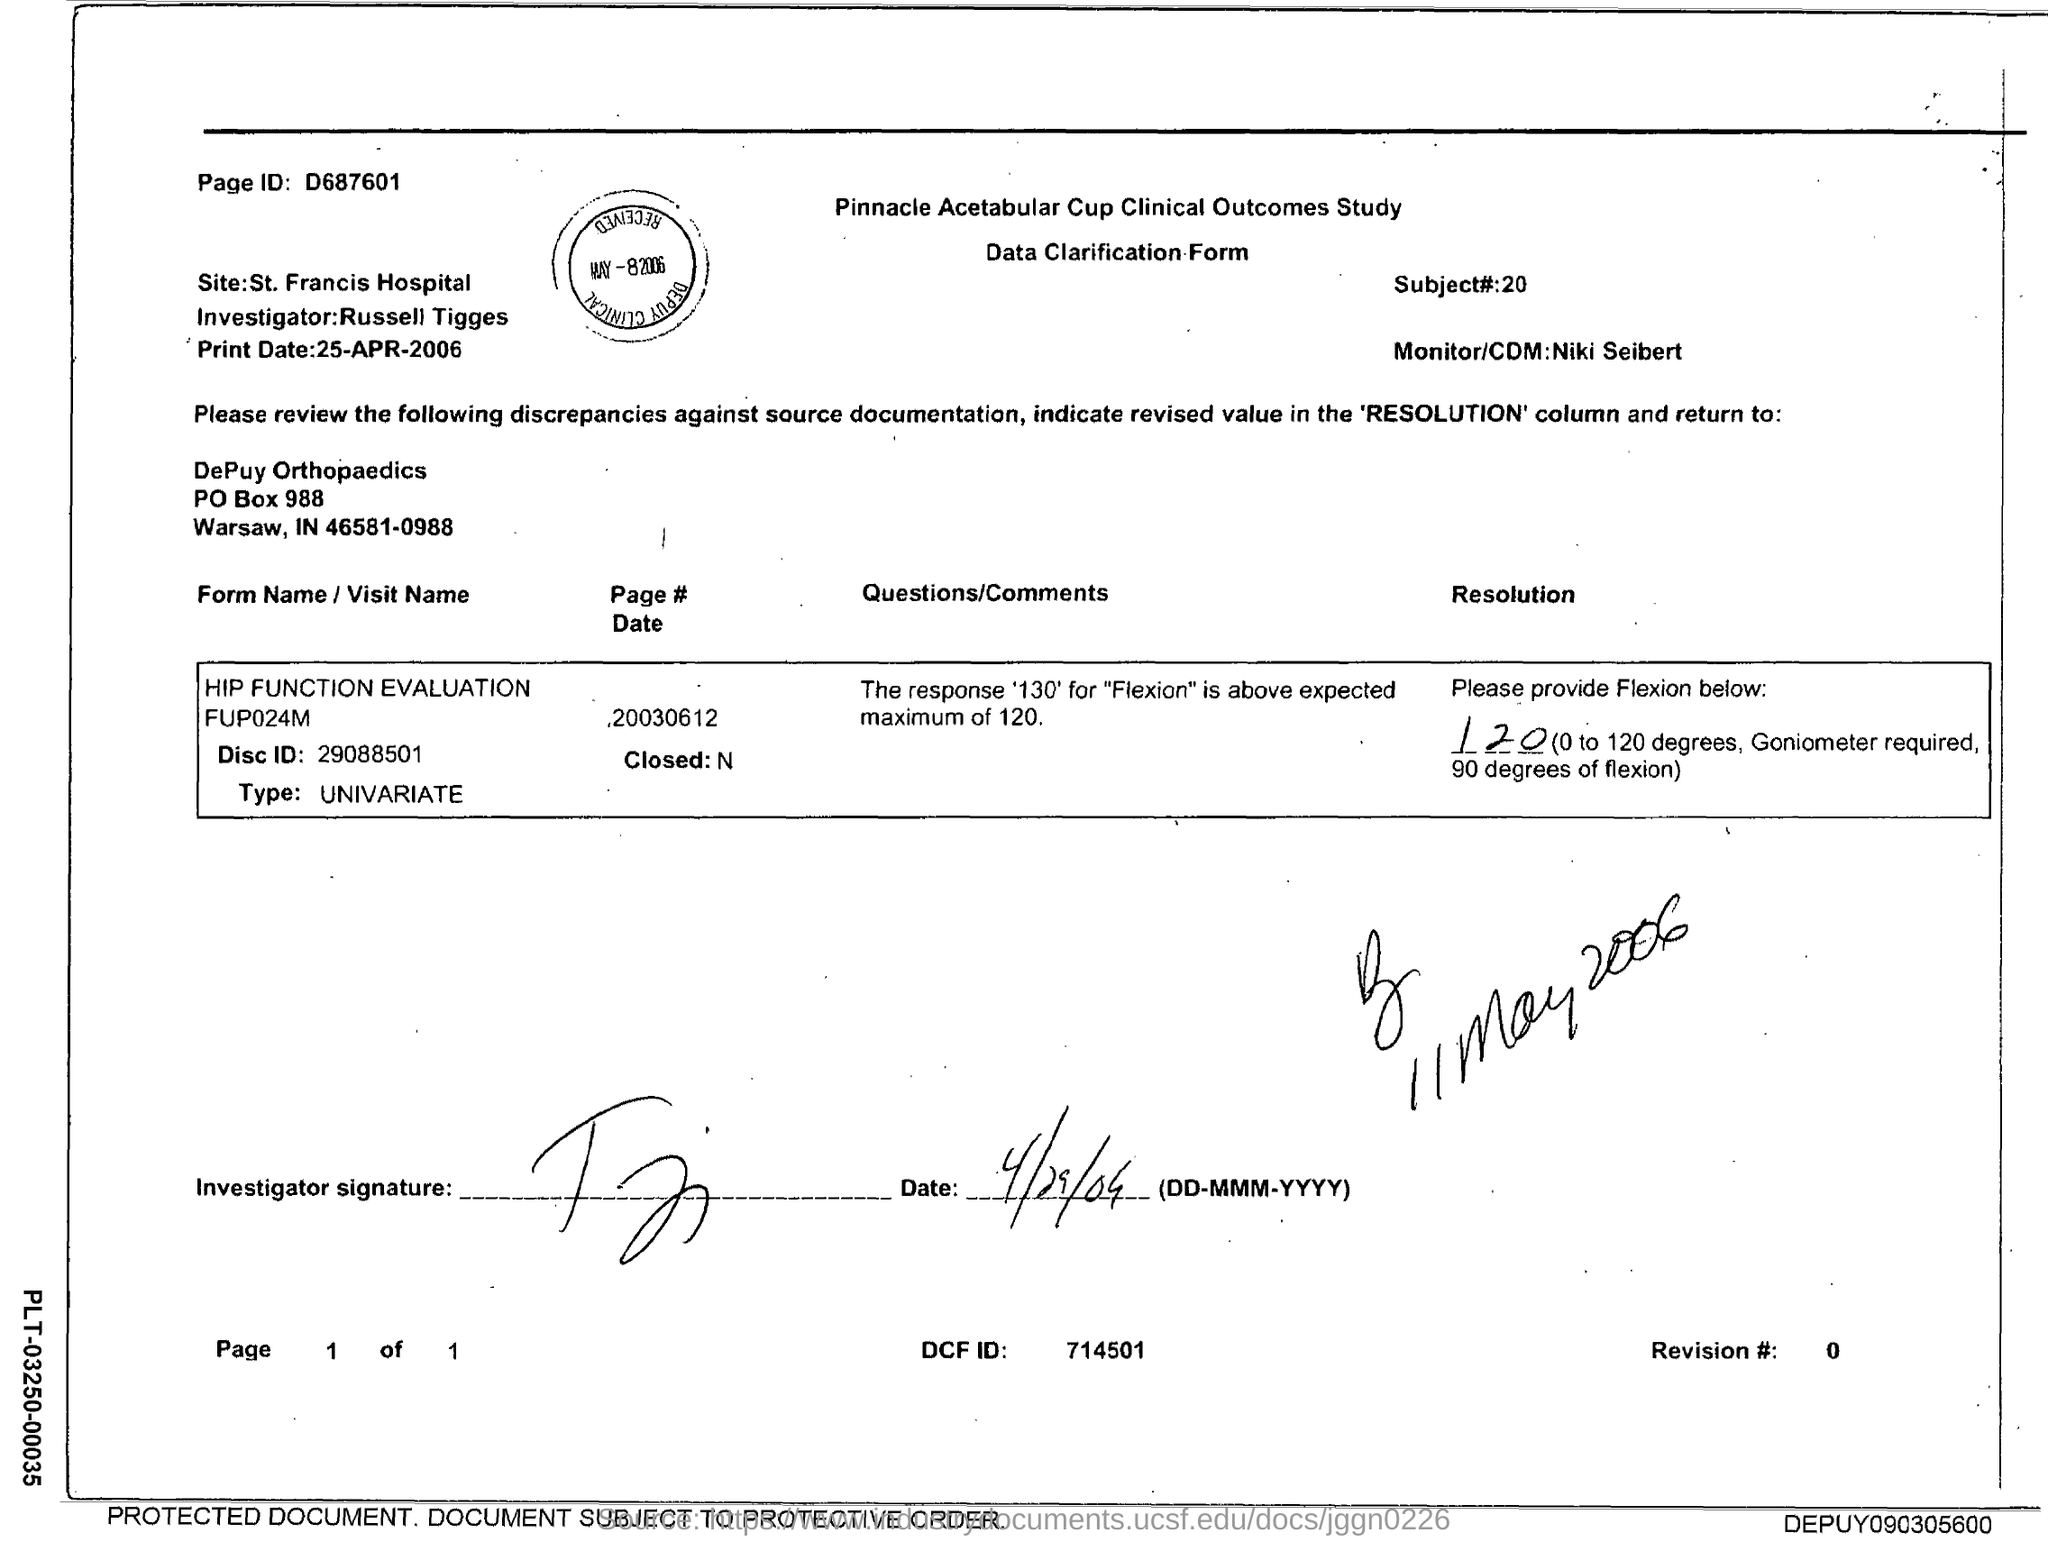What is the page id in the mentioned document?
Your answer should be very brief. D687601. What is the PO Box Number mentioned in the document?
Provide a short and direct response. 988. What is the name of the Investigator?
Your answer should be compact. Russell Tigges. What is the Subject# number?
Your answer should be compact. 20. Who is the Monitor/CDM?
Provide a succinct answer. Niki Seibert. 